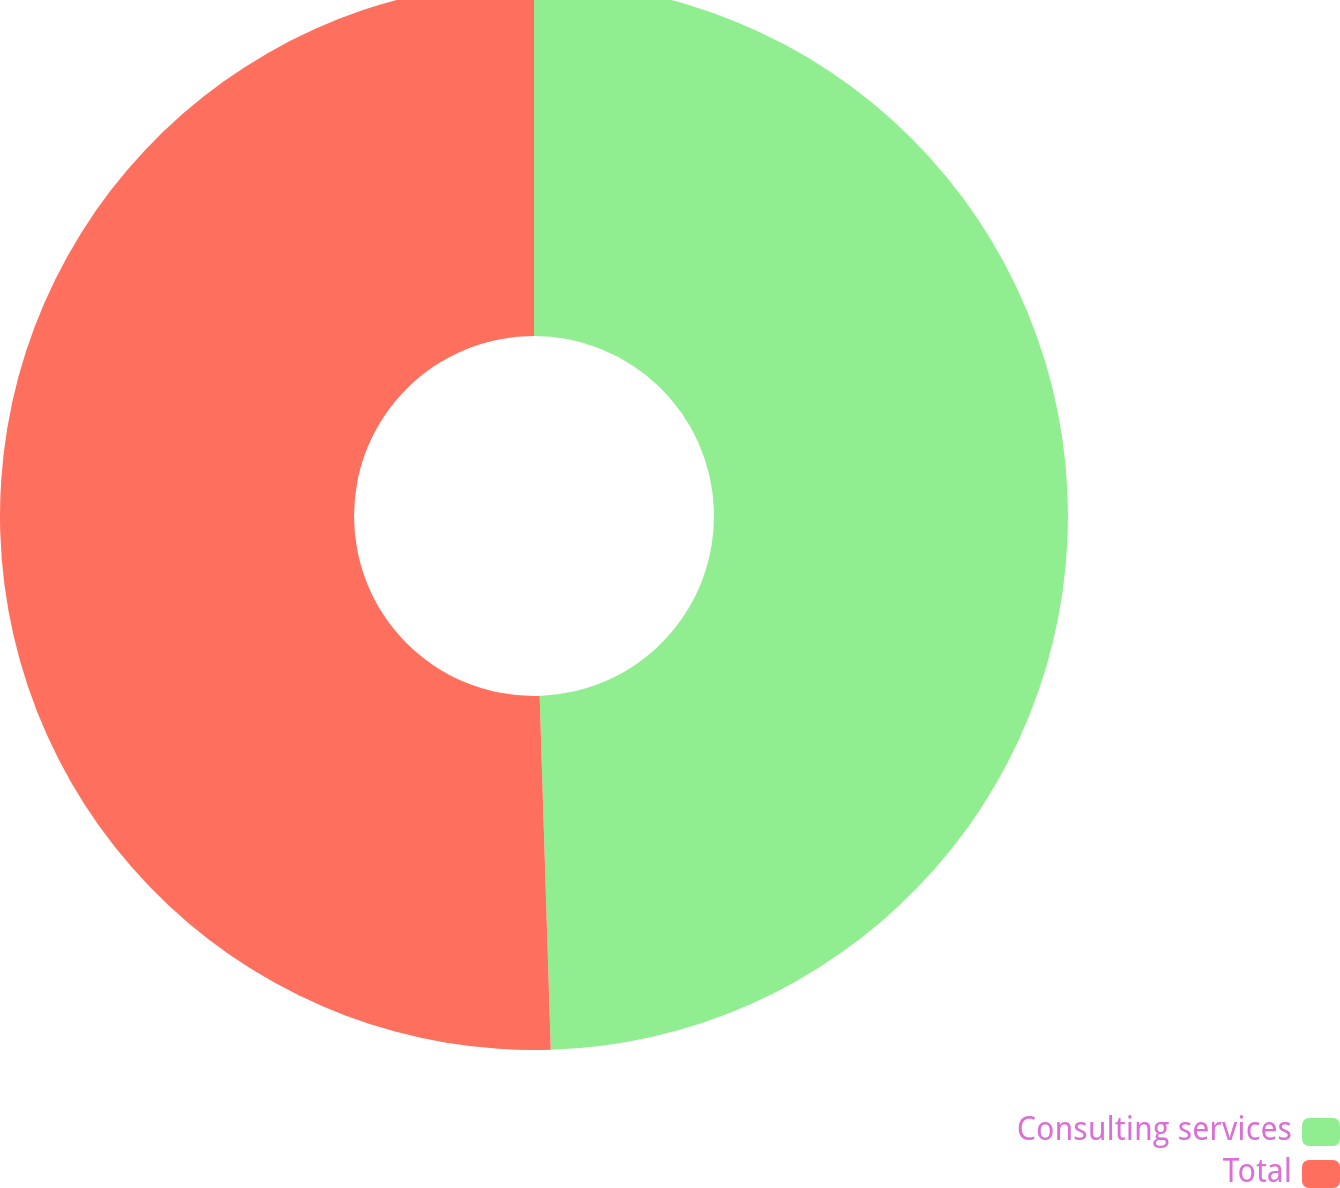Convert chart. <chart><loc_0><loc_0><loc_500><loc_500><pie_chart><fcel>Consulting services<fcel>Total<nl><fcel>49.5%<fcel>50.5%<nl></chart> 